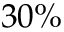<formula> <loc_0><loc_0><loc_500><loc_500>3 0 \%</formula> 